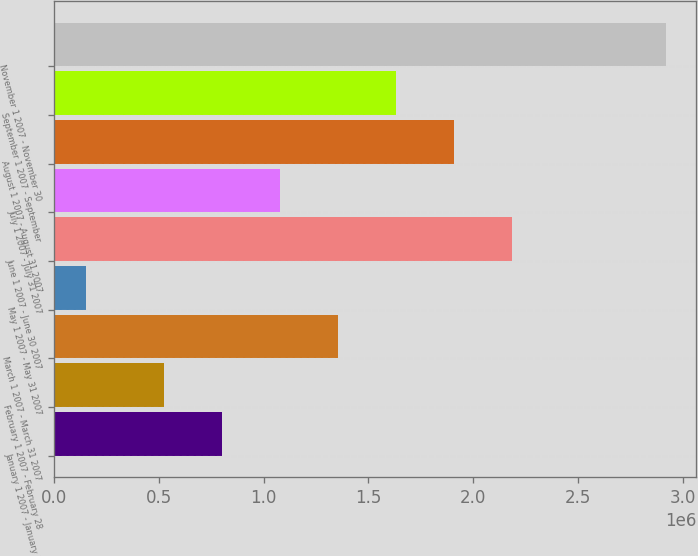Convert chart. <chart><loc_0><loc_0><loc_500><loc_500><bar_chart><fcel>January 1 2007 - January 31<fcel>February 1 2007 - February 28<fcel>March 1 2007 - March 31 2007<fcel>May 1 2007 - May 31 2007<fcel>June 1 2007 - June 30 2007<fcel>July 1 2007 - July 31 2007<fcel>August 1 2007 - August 31 2007<fcel>September 1 2007 - September<fcel>November 1 2007 - November 30<nl><fcel>800425<fcel>523900<fcel>1.35347e+06<fcel>152398<fcel>2.18305e+06<fcel>1.07695e+06<fcel>1.90652e+06<fcel>1.63e+06<fcel>2.91764e+06<nl></chart> 